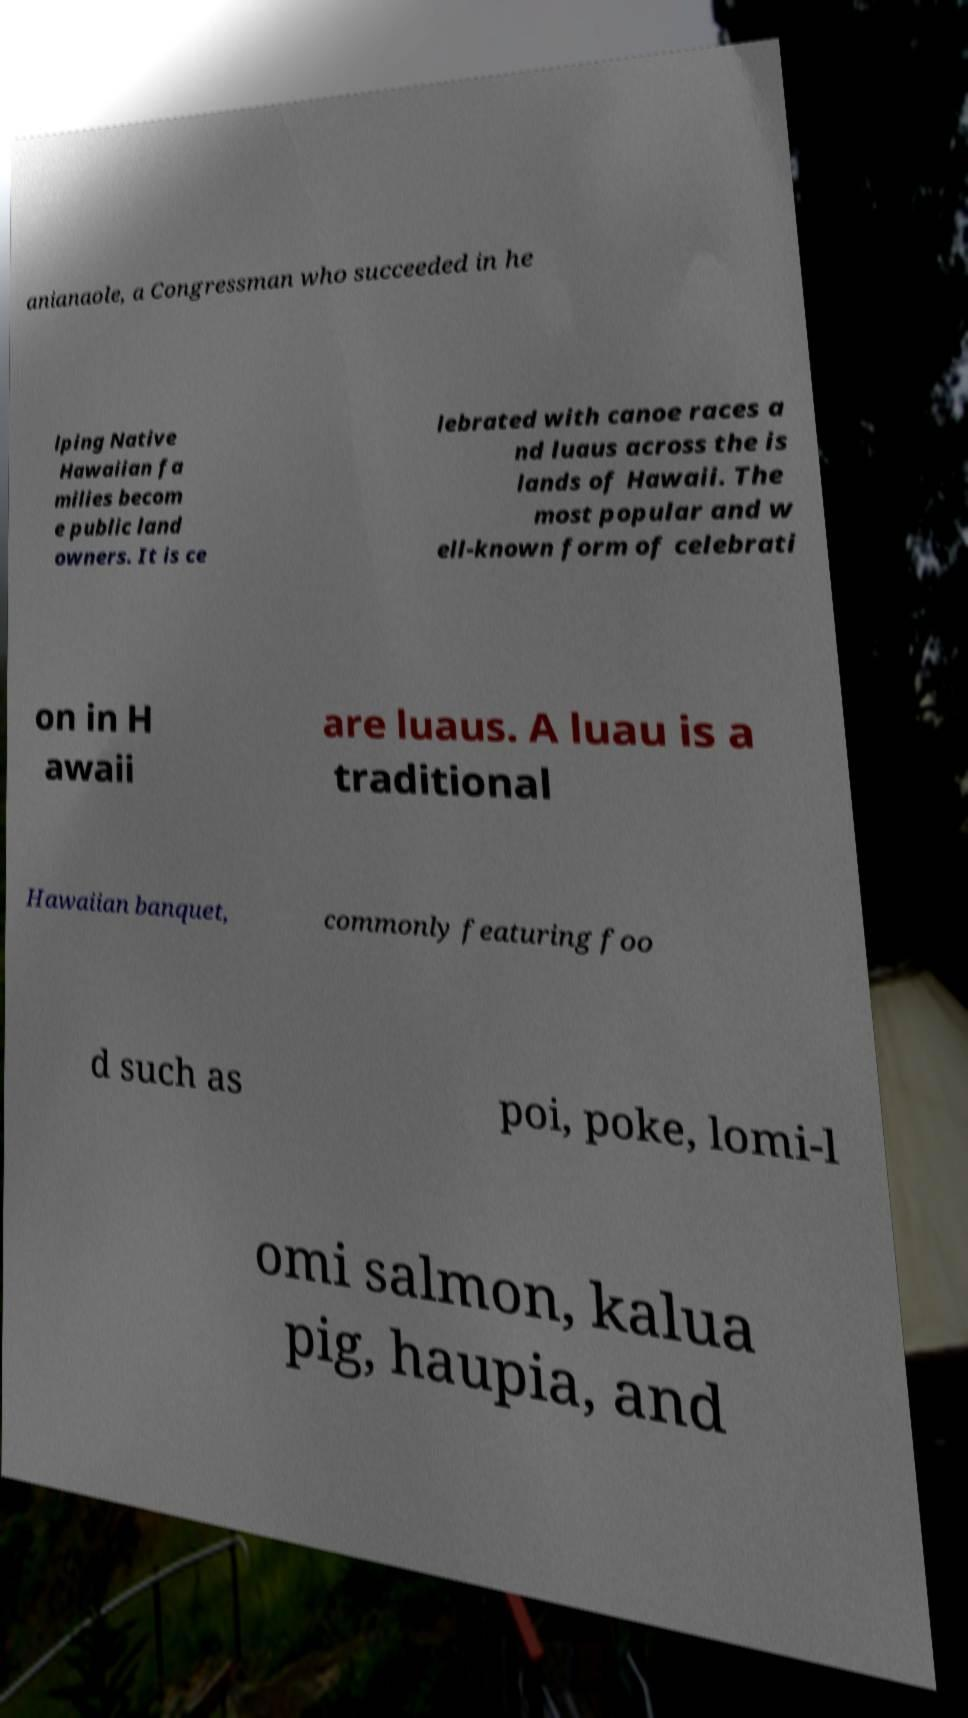For documentation purposes, I need the text within this image transcribed. Could you provide that? anianaole, a Congressman who succeeded in he lping Native Hawaiian fa milies becom e public land owners. It is ce lebrated with canoe races a nd luaus across the is lands of Hawaii. The most popular and w ell-known form of celebrati on in H awaii are luaus. A luau is a traditional Hawaiian banquet, commonly featuring foo d such as poi, poke, lomi-l omi salmon, kalua pig, haupia, and 